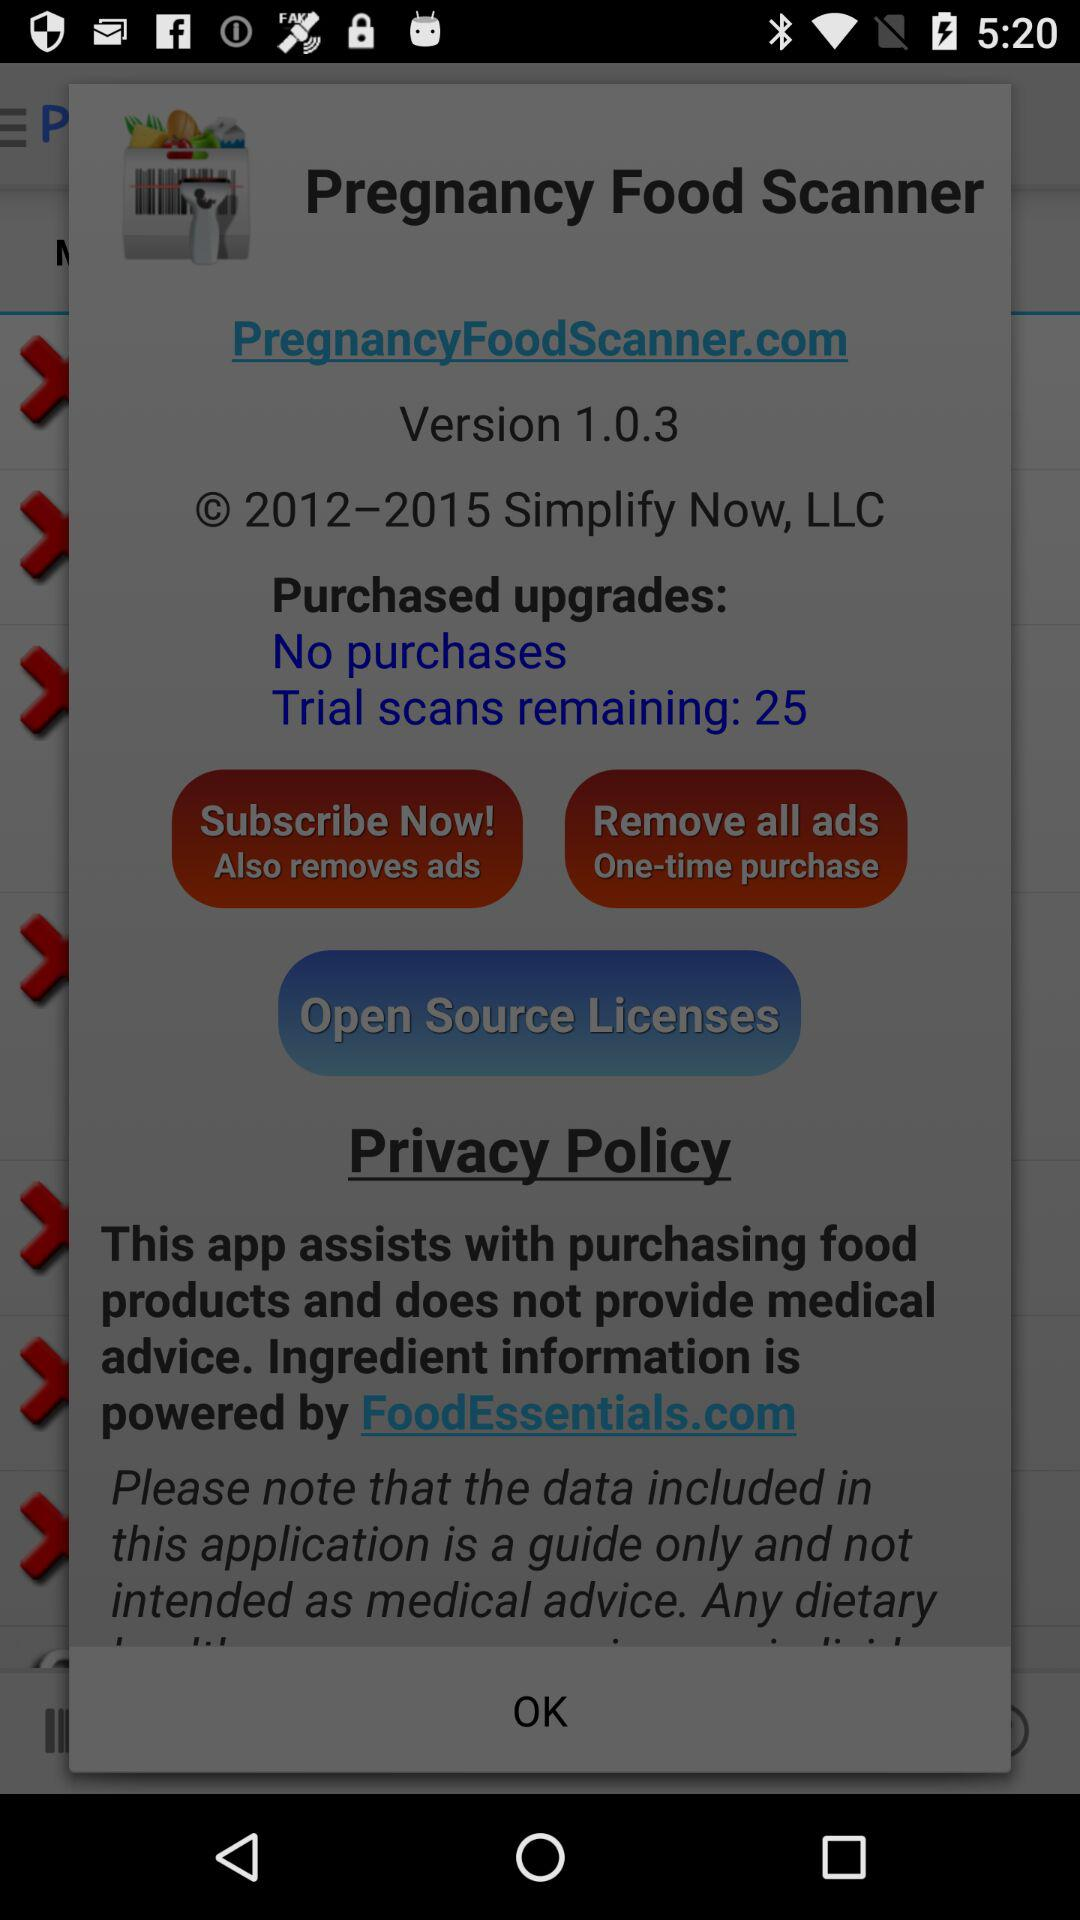What is the year of copyright for the application? The copyright for the application is from 2012 to 2015. 